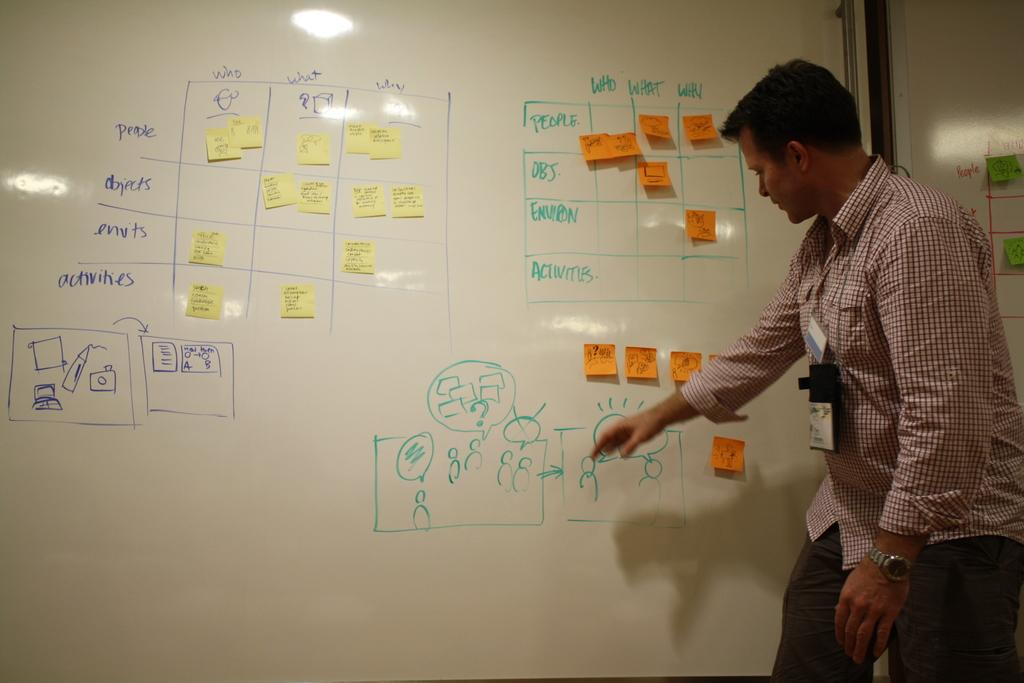<image>
Give a short and clear explanation of the subsequent image. Man giving a presentation on a white board that reads "Who,What,Why" at the top. 